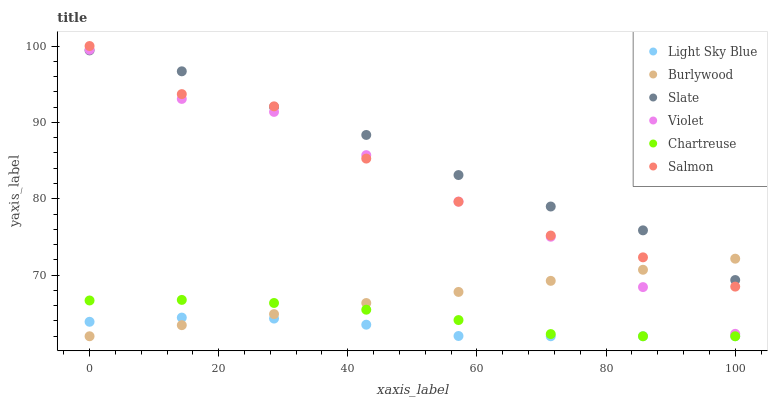Does Light Sky Blue have the minimum area under the curve?
Answer yes or no. Yes. Does Slate have the maximum area under the curve?
Answer yes or no. Yes. Does Salmon have the minimum area under the curve?
Answer yes or no. No. Does Salmon have the maximum area under the curve?
Answer yes or no. No. Is Burlywood the smoothest?
Answer yes or no. Yes. Is Salmon the roughest?
Answer yes or no. Yes. Is Slate the smoothest?
Answer yes or no. No. Is Slate the roughest?
Answer yes or no. No. Does Burlywood have the lowest value?
Answer yes or no. Yes. Does Salmon have the lowest value?
Answer yes or no. No. Does Salmon have the highest value?
Answer yes or no. Yes. Does Slate have the highest value?
Answer yes or no. No. Is Chartreuse less than Salmon?
Answer yes or no. Yes. Is Slate greater than Chartreuse?
Answer yes or no. Yes. Does Burlywood intersect Violet?
Answer yes or no. Yes. Is Burlywood less than Violet?
Answer yes or no. No. Is Burlywood greater than Violet?
Answer yes or no. No. Does Chartreuse intersect Salmon?
Answer yes or no. No. 